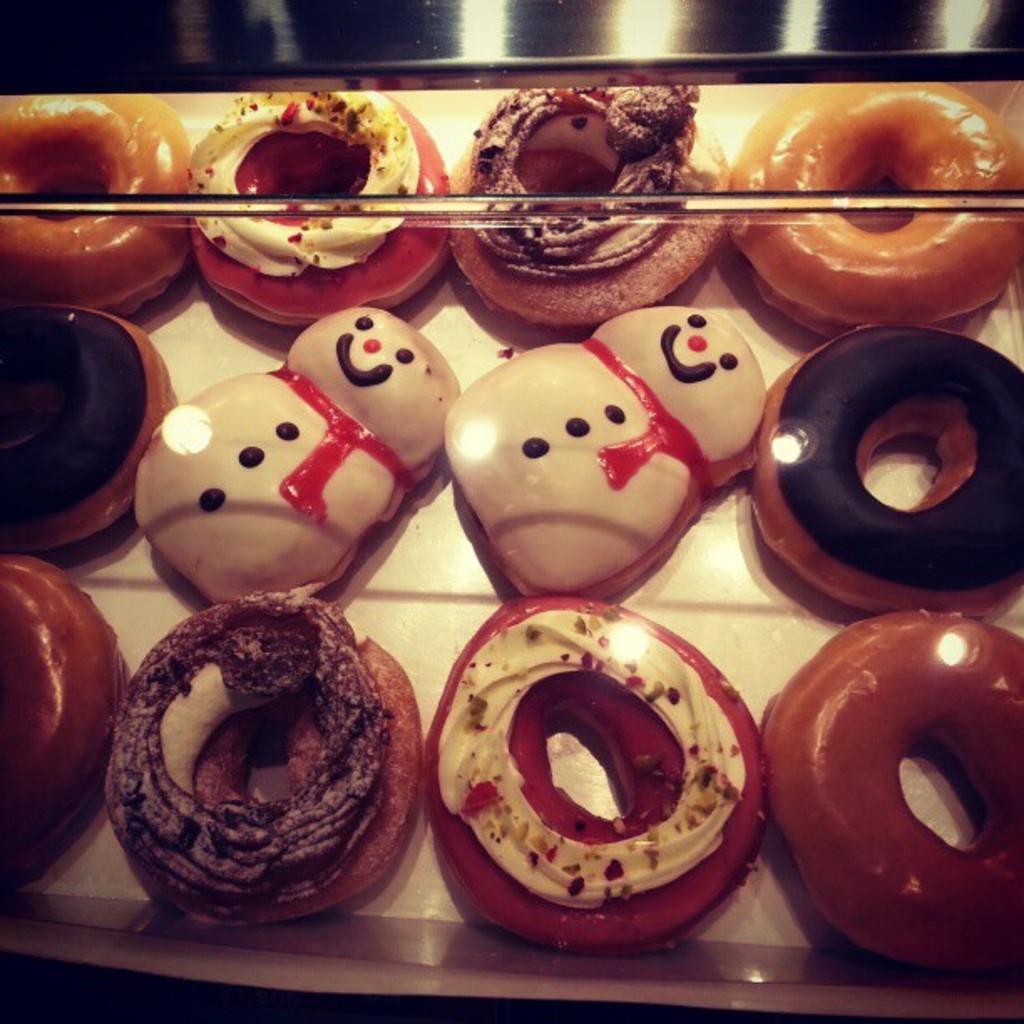Could you give a brief overview of what you see in this image? In this image, I can see different varieties of doughnuts, which are placed in a tray. 